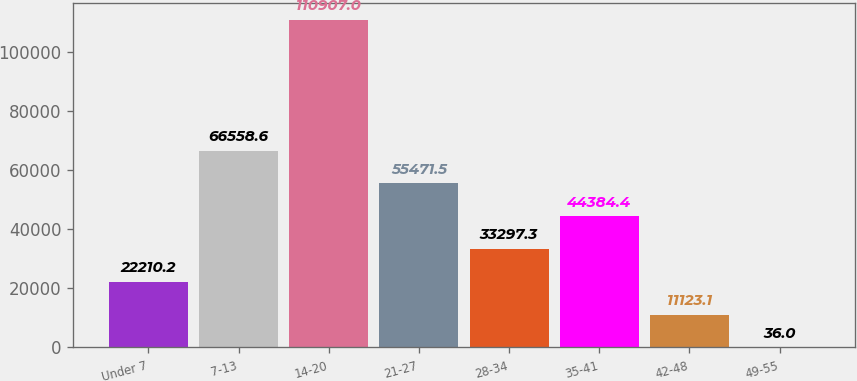Convert chart. <chart><loc_0><loc_0><loc_500><loc_500><bar_chart><fcel>Under 7<fcel>7-13<fcel>14-20<fcel>21-27<fcel>28-34<fcel>35-41<fcel>42-48<fcel>49-55<nl><fcel>22210.2<fcel>66558.6<fcel>110907<fcel>55471.5<fcel>33297.3<fcel>44384.4<fcel>11123.1<fcel>36<nl></chart> 